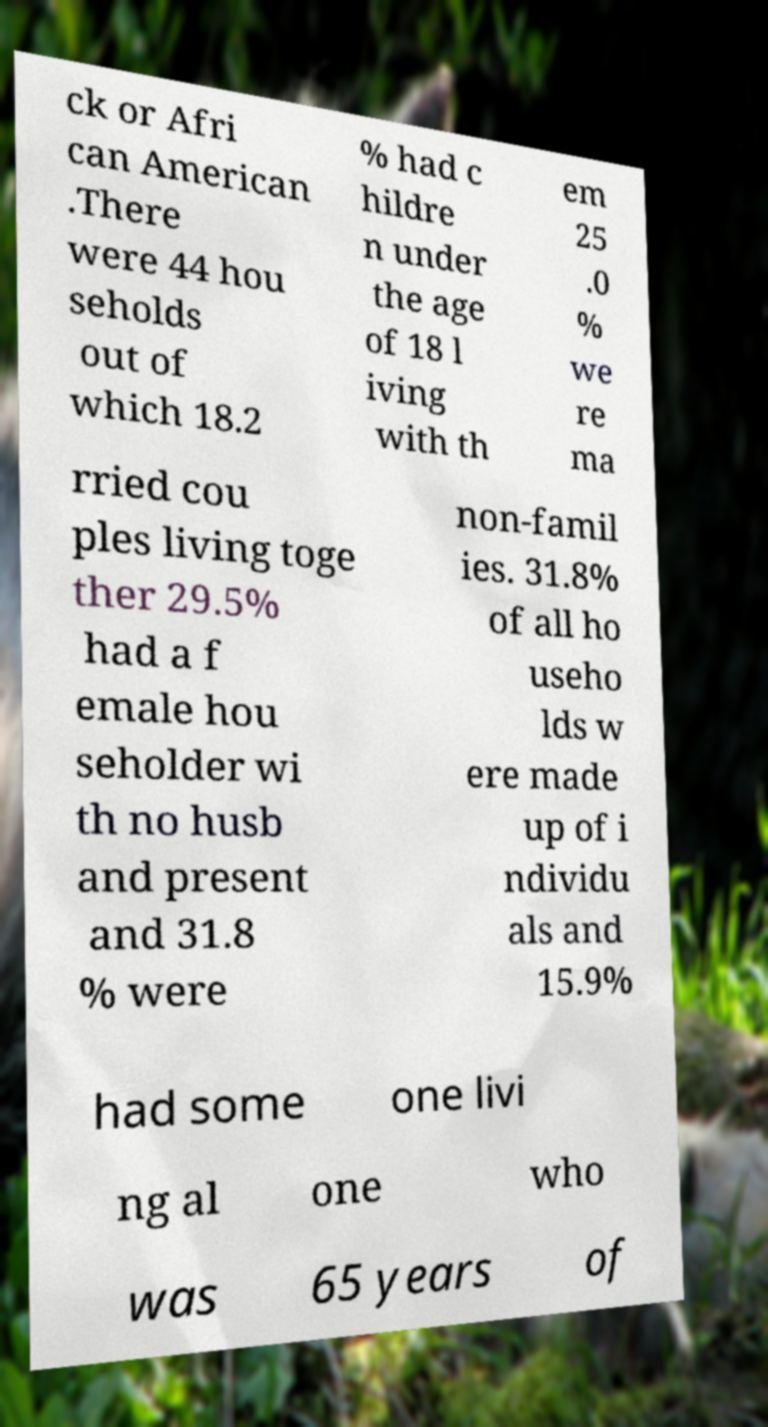Could you extract and type out the text from this image? ck or Afri can American .There were 44 hou seholds out of which 18.2 % had c hildre n under the age of 18 l iving with th em 25 .0 % we re ma rried cou ples living toge ther 29.5% had a f emale hou seholder wi th no husb and present and 31.8 % were non-famil ies. 31.8% of all ho useho lds w ere made up of i ndividu als and 15.9% had some one livi ng al one who was 65 years of 